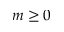Convert formula to latex. <formula><loc_0><loc_0><loc_500><loc_500>m \geq 0</formula> 